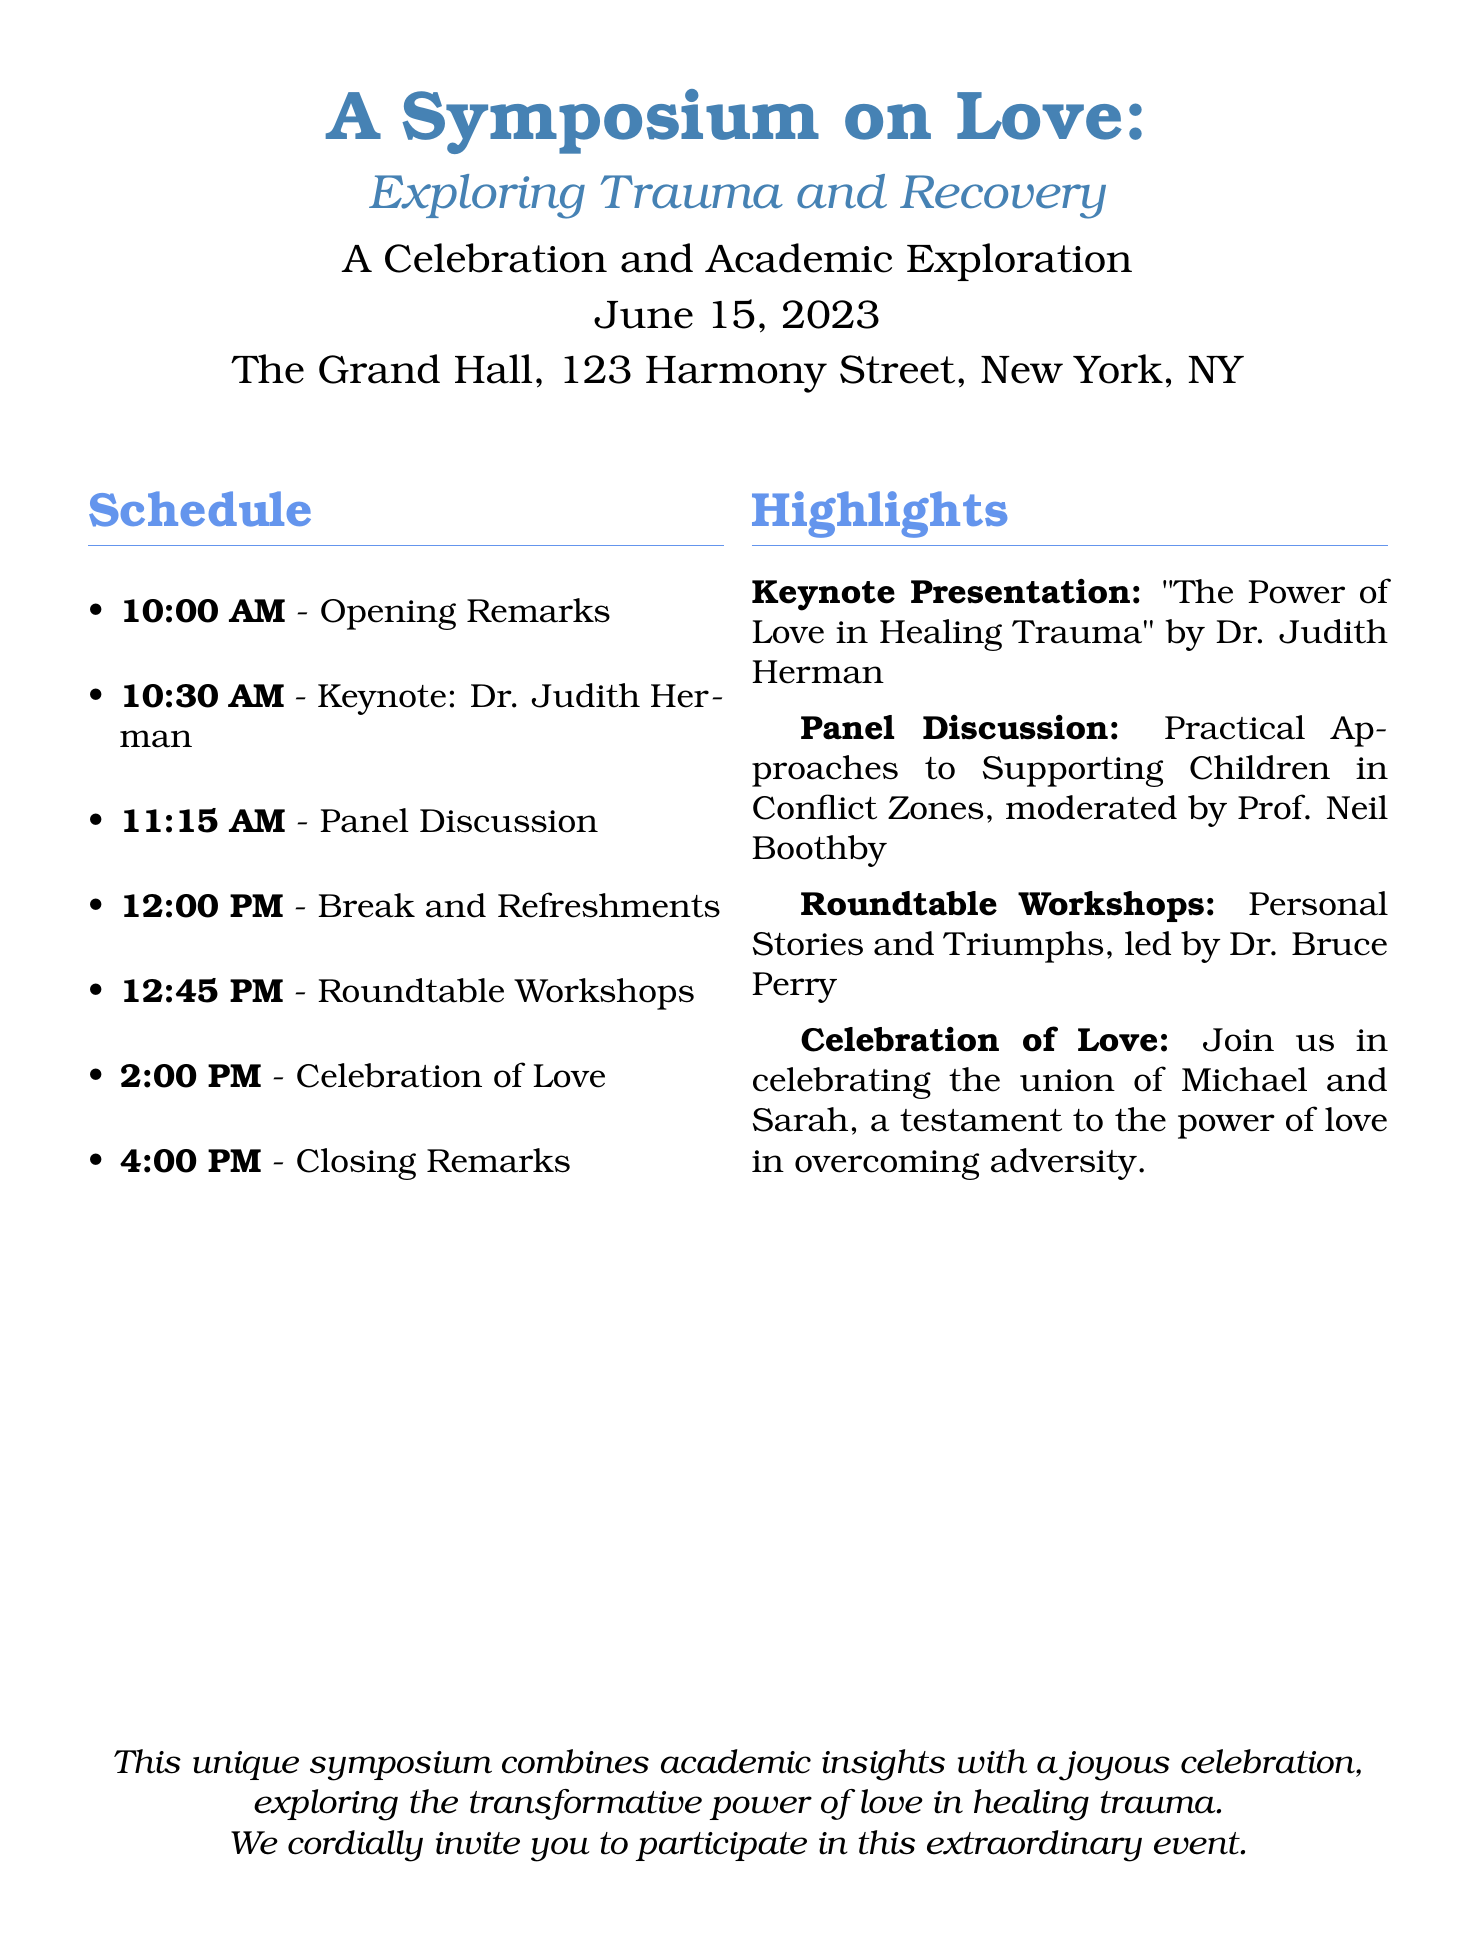What is the date of the symposium? The date is mentioned in the document as June 15, 2023.
Answer: June 15, 2023 Who is the keynote speaker? The keynote speaker's name is provided in the document as Dr. Judith Herman.
Answer: Dr. Judith Herman What is the location of the event? The location is stated in the document as The Grand Hall, 123 Harmony Street, New York, NY.
Answer: The Grand Hall, 123 Harmony Street, New York, NY What time does the celebration of love begin? The time for the celebration of love is listed as 2:00 PM in the document.
Answer: 2:00 PM Which panel discussion is moderated by Prof. Neil Boothby? The document specifies that the panel discussion is on "Practical Approaches to Supporting Children in Conflict Zones."
Answer: Practical Approaches to Supporting Children in Conflict Zones What is the overarching theme of the symposium? The theme is encapsulated in the title of the event, which focuses on love and its connection to trauma and recovery.
Answer: Exploring Trauma and Recovery What is the purpose of the roundtable workshops? The document indicates that the workshops revolve around sharing personal stories and triumphs.
Answer: Personal Stories and Triumphs What is unique about this symposium compared to traditional weddings? The document emphasizes that this event combines academic insights with a celebration, highlighting its unique focus on trauma and love.
Answer: Academic insights with a celebration 